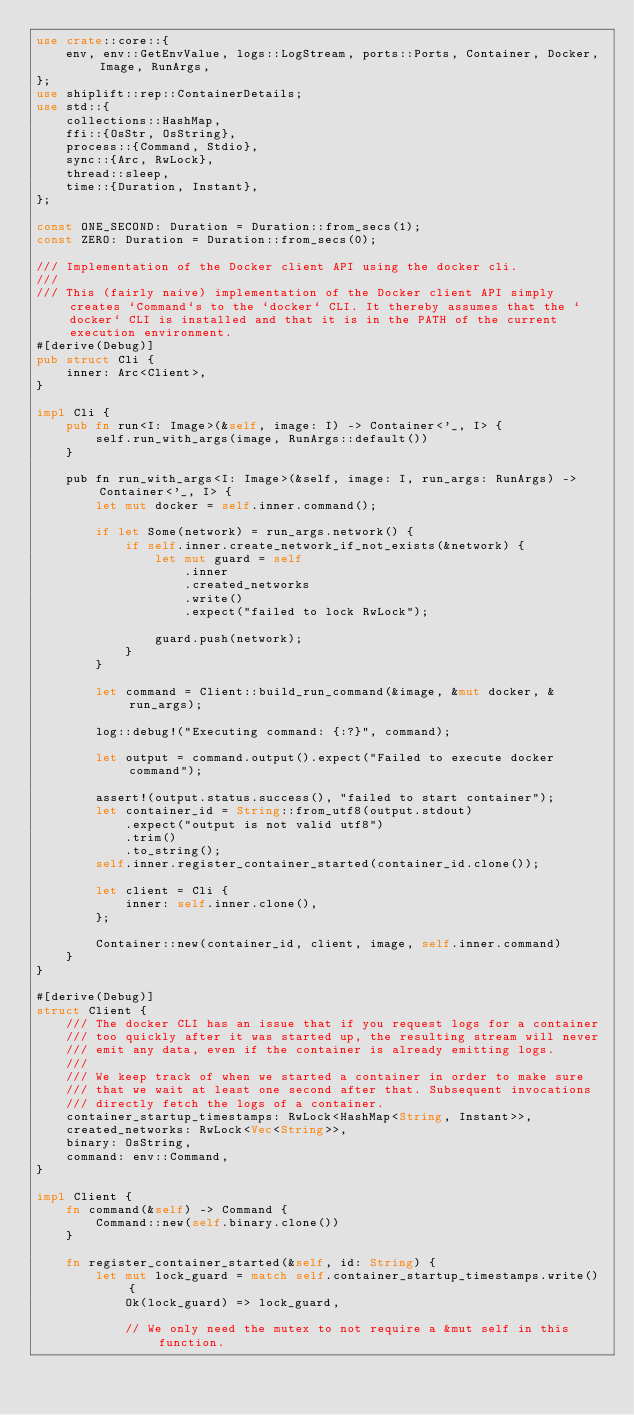Convert code to text. <code><loc_0><loc_0><loc_500><loc_500><_Rust_>use crate::core::{
    env, env::GetEnvValue, logs::LogStream, ports::Ports, Container, Docker, Image, RunArgs,
};
use shiplift::rep::ContainerDetails;
use std::{
    collections::HashMap,
    ffi::{OsStr, OsString},
    process::{Command, Stdio},
    sync::{Arc, RwLock},
    thread::sleep,
    time::{Duration, Instant},
};

const ONE_SECOND: Duration = Duration::from_secs(1);
const ZERO: Duration = Duration::from_secs(0);

/// Implementation of the Docker client API using the docker cli.
///
/// This (fairly naive) implementation of the Docker client API simply creates `Command`s to the `docker` CLI. It thereby assumes that the `docker` CLI is installed and that it is in the PATH of the current execution environment.
#[derive(Debug)]
pub struct Cli {
    inner: Arc<Client>,
}

impl Cli {
    pub fn run<I: Image>(&self, image: I) -> Container<'_, I> {
        self.run_with_args(image, RunArgs::default())
    }

    pub fn run_with_args<I: Image>(&self, image: I, run_args: RunArgs) -> Container<'_, I> {
        let mut docker = self.inner.command();

        if let Some(network) = run_args.network() {
            if self.inner.create_network_if_not_exists(&network) {
                let mut guard = self
                    .inner
                    .created_networks
                    .write()
                    .expect("failed to lock RwLock");

                guard.push(network);
            }
        }

        let command = Client::build_run_command(&image, &mut docker, &run_args);

        log::debug!("Executing command: {:?}", command);

        let output = command.output().expect("Failed to execute docker command");

        assert!(output.status.success(), "failed to start container");
        let container_id = String::from_utf8(output.stdout)
            .expect("output is not valid utf8")
            .trim()
            .to_string();
        self.inner.register_container_started(container_id.clone());

        let client = Cli {
            inner: self.inner.clone(),
        };

        Container::new(container_id, client, image, self.inner.command)
    }
}

#[derive(Debug)]
struct Client {
    /// The docker CLI has an issue that if you request logs for a container
    /// too quickly after it was started up, the resulting stream will never
    /// emit any data, even if the container is already emitting logs.
    ///
    /// We keep track of when we started a container in order to make sure
    /// that we wait at least one second after that. Subsequent invocations
    /// directly fetch the logs of a container.
    container_startup_timestamps: RwLock<HashMap<String, Instant>>,
    created_networks: RwLock<Vec<String>>,
    binary: OsString,
    command: env::Command,
}

impl Client {
    fn command(&self) -> Command {
        Command::new(self.binary.clone())
    }

    fn register_container_started(&self, id: String) {
        let mut lock_guard = match self.container_startup_timestamps.write() {
            Ok(lock_guard) => lock_guard,

            // We only need the mutex to not require a &mut self in this function.</code> 